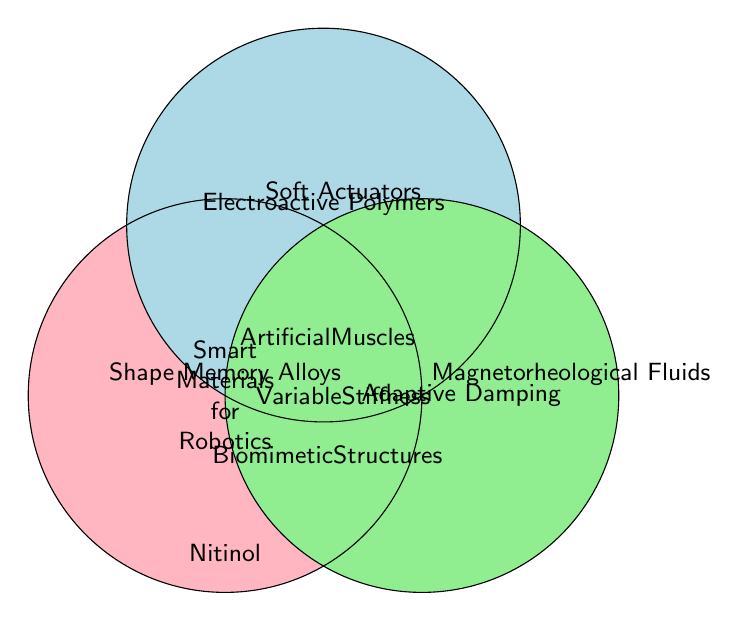What three main types of smart materials are highlighted in the Venn Diagram? There are three main circles, each labeled with a type of smart material. These are "Shape Memory Alloys," "Electroactive Polymers," and "Magnetorheological Fluids."
Answer: Shape Memory Alloys, Electroactive Polymers, Magnetorheological Fluids Which smart material is associated with "Adaptive Damping"? The text "Adaptive Damping" is placed within the circle labeled "Magnetorheological Fluids," indicating the association.
Answer: Magnetorheological Fluids Where is "Nitinol" placed in the Venn Diagram? "Nitinol" is placed at the bottom of the diagram, within the circle labeled "Shape Memory Alloys."
Answer: Shape Memory Alloys What shared application is placed in the overlapping area of all three circles? In the center, where all three circles overlap, there is a text "Smart Materials for Robotics," indicating the shared application across all three material types.
Answer: Smart Materials for Robotics Which applications are unique to "Electroactive Polymers"? The labels unique to the "Electroactive Polymers" circle and not in any other overlapping areas include "Artificial Muscles" and "Soft Actuators."
Answer: Artificial Muscles, Soft Actuators What function is related to all materials used in flexible robotic systems? In the center where all three circles overlap, the text "Smart Materials for Robotics" is mentioned, suggesting this function is a common application for all materials.
Answer: Smart Materials for Robotics Describe where "Variable Stiffness" is located in the Venn Diagram. The text "Variable Stiffness" is placed between "Shape Memory Alloys" and "Magnetorheological Fluids" but outside the "Electroactive Polymers" circle, indicating it's shared between those two.
Answer: Between Shape Memory Alloys and Magnetorheological Fluids Identify a material that contributes to "Soft Actuators". "Soft Actuators" is located within the circle labeled "Electroactive Polymers."
Answer: Electroactive Polymers 